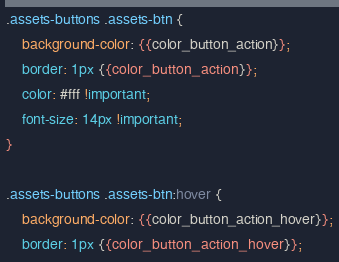<code> <loc_0><loc_0><loc_500><loc_500><_CSS_>.assets-buttons .assets-btn {
	background-color: {{color_button_action}};
	border: 1px {{color_button_action}};
	color: #fff !important;
	font-size: 14px !important;
}

.assets-buttons .assets-btn:hover {
	background-color: {{color_button_action_hover}};
	border: 1px {{color_button_action_hover}};</code> 